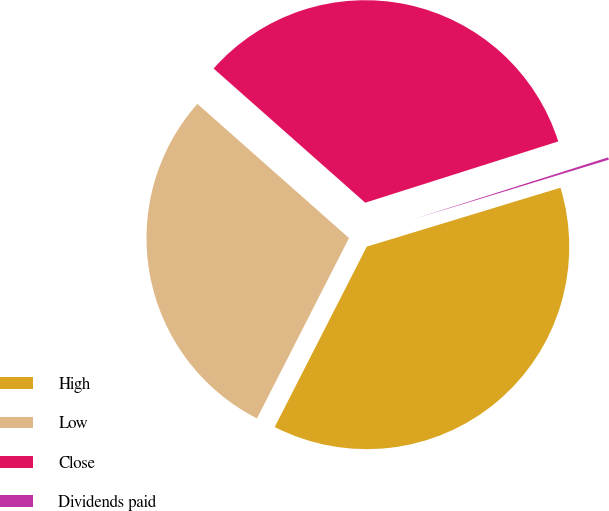Convert chart. <chart><loc_0><loc_0><loc_500><loc_500><pie_chart><fcel>High<fcel>Low<fcel>Close<fcel>Dividends paid<nl><fcel>37.21%<fcel>29.02%<fcel>33.58%<fcel>0.19%<nl></chart> 